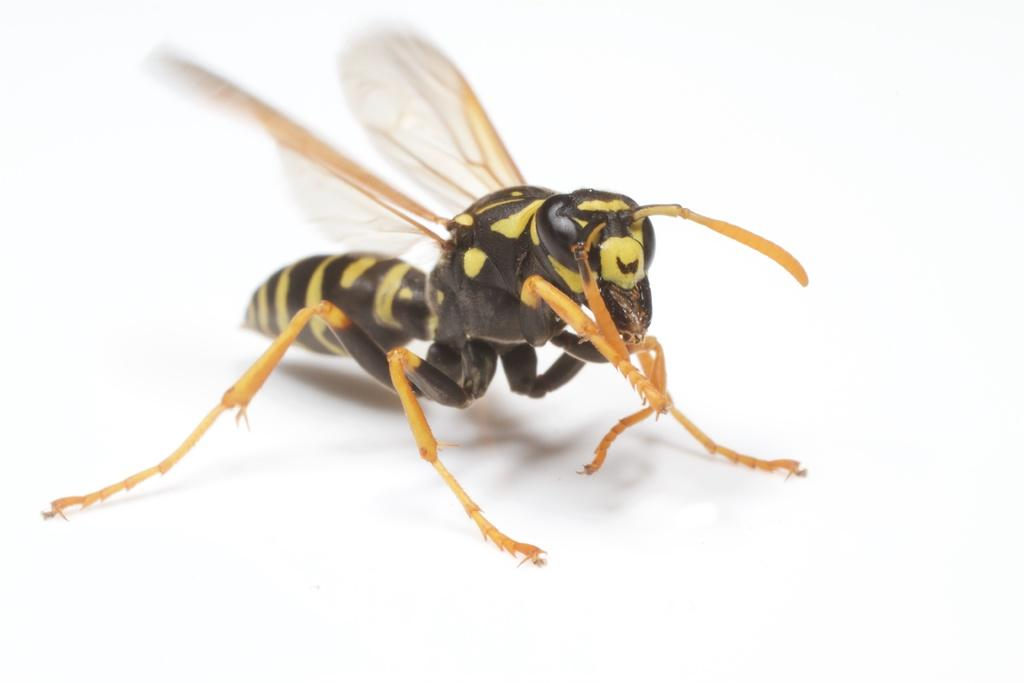What type of insect is in the image? There is a potter wasp in the image. What is the background or surface on which the potter wasp is located? The potter wasp is on a white surface. How many times does the spark flock around the potter wasp in the image? There is no spark or flocking present in the image; it only features a potter wasp on a white surface. 